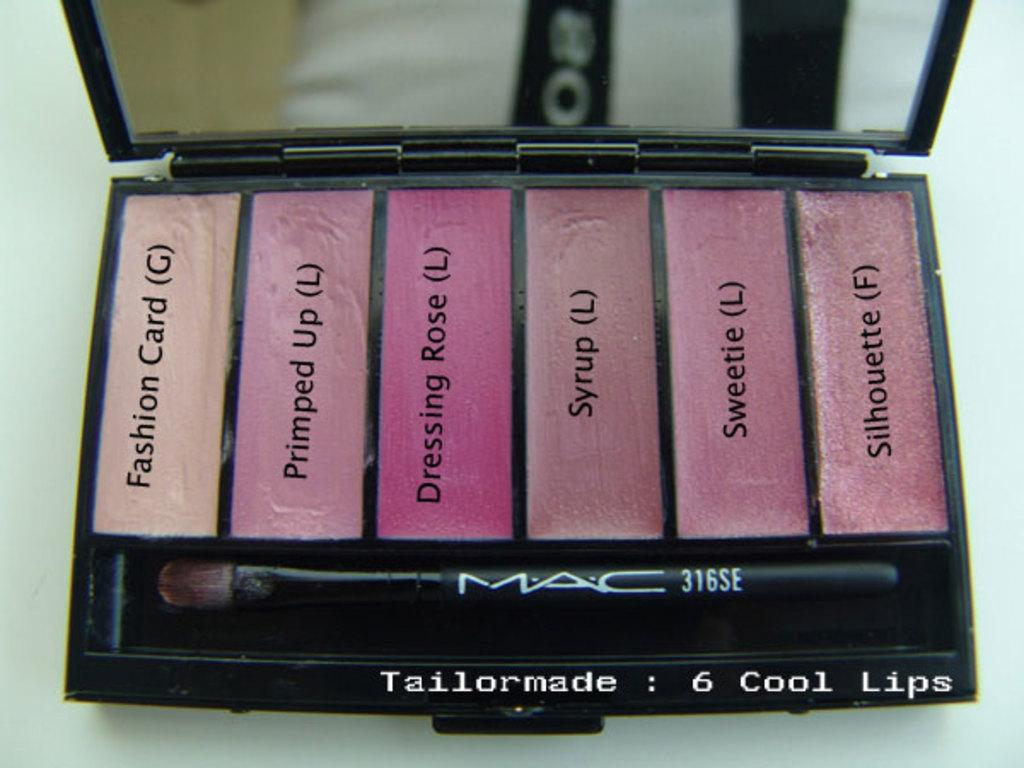<image>
Relay a brief, clear account of the picture shown. A Mac cosmetics compact has lip colors that include Syrup and Sweetie. 